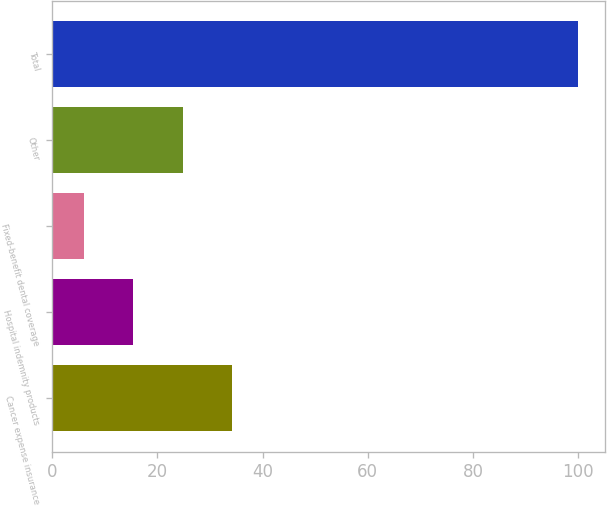<chart> <loc_0><loc_0><loc_500><loc_500><bar_chart><fcel>Cancer expense insurance<fcel>Hospital indemnity products<fcel>Fixed-benefit dental coverage<fcel>Other<fcel>Total<nl><fcel>34.2<fcel>15.4<fcel>6<fcel>24.8<fcel>100<nl></chart> 